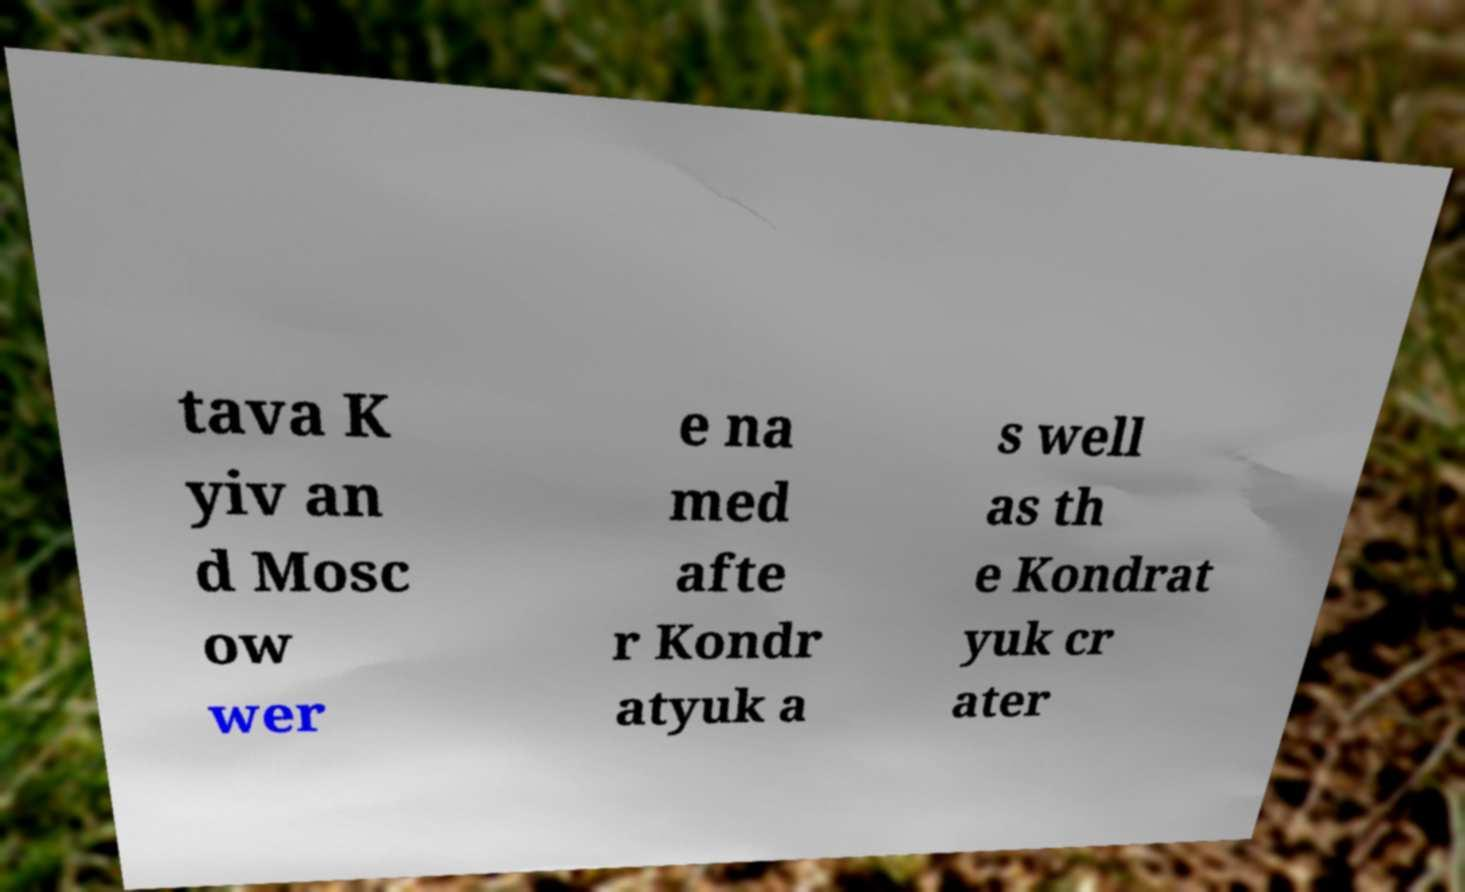I need the written content from this picture converted into text. Can you do that? tava K yiv an d Mosc ow wer e na med afte r Kondr atyuk a s well as th e Kondrat yuk cr ater 